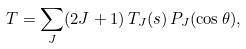Convert formula to latex. <formula><loc_0><loc_0><loc_500><loc_500>T = \sum _ { J } ( 2 J + 1 ) \, T _ { J } ( s ) \, P _ { J } ( \cos \theta ) ,</formula> 